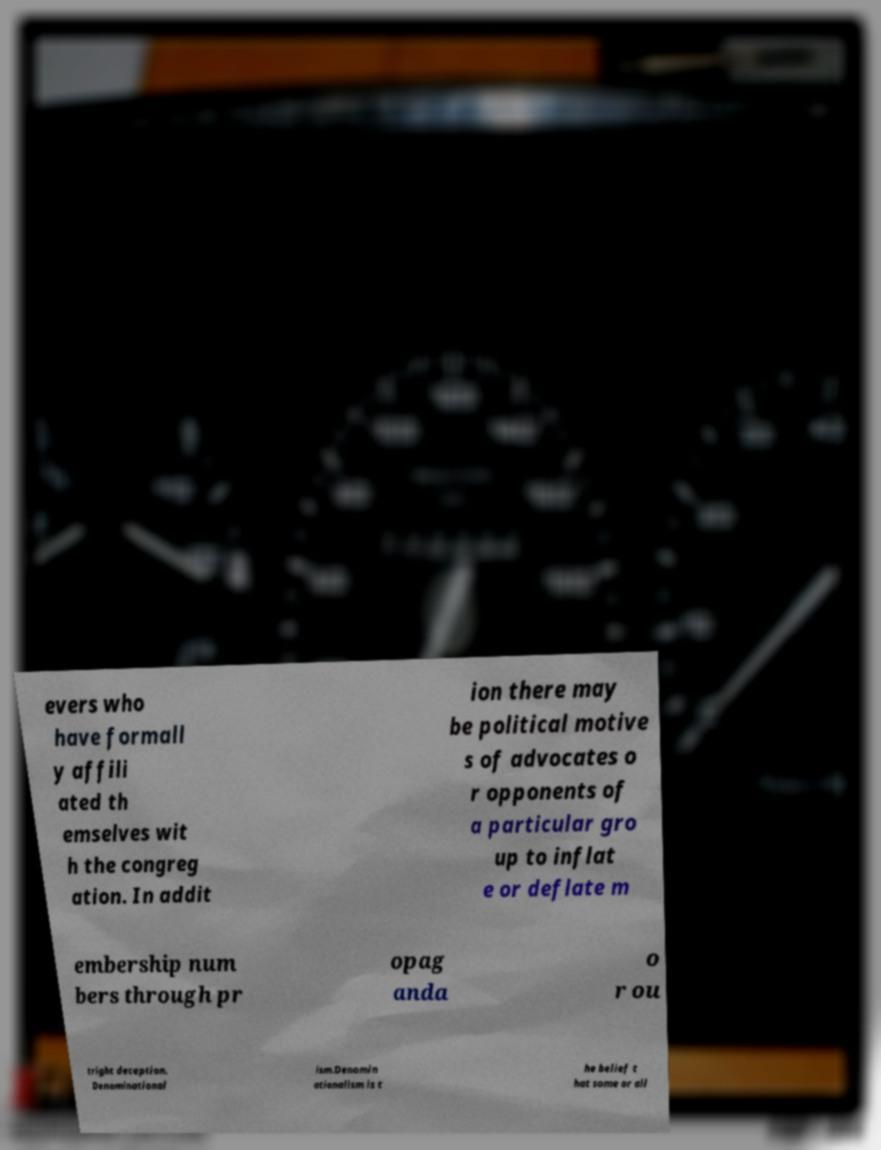I need the written content from this picture converted into text. Can you do that? evers who have formall y affili ated th emselves wit h the congreg ation. In addit ion there may be political motive s of advocates o r opponents of a particular gro up to inflat e or deflate m embership num bers through pr opag anda o r ou tright deception. Denominational ism.Denomin ationalism is t he belief t hat some or all 